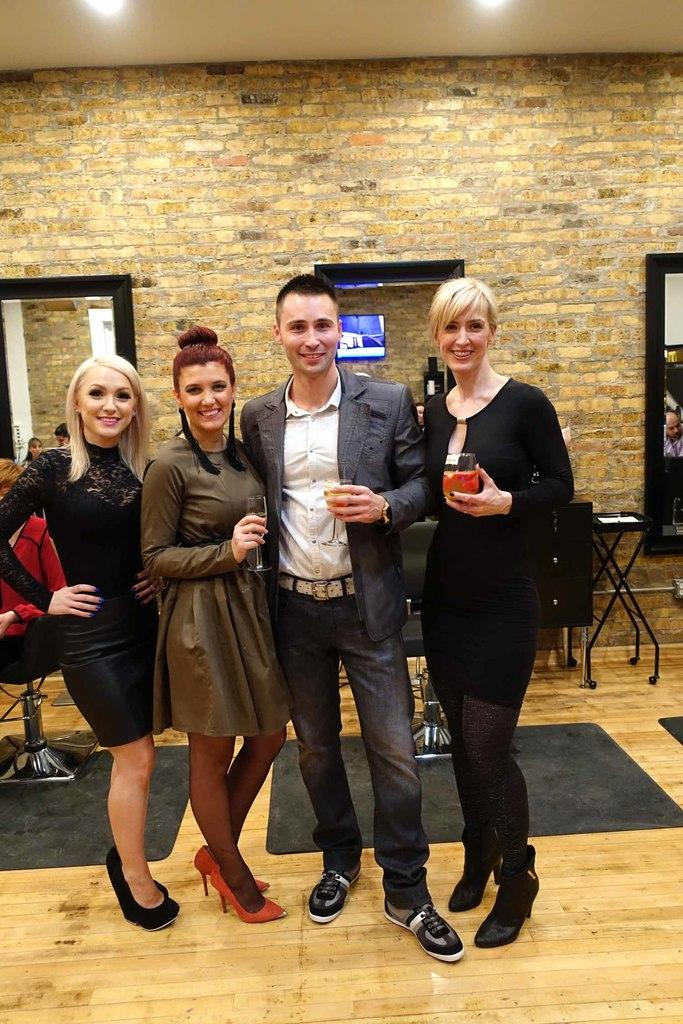What are the people in the image doing? The people in the image are standing in the center. What can be seen behind the people? There is a wall in the background of the image. What is visible at the top of the image? There is a ceiling with lights at the top of the image. How many tomatoes can be seen on the ground in the image? There are no tomatoes visible in the image. 